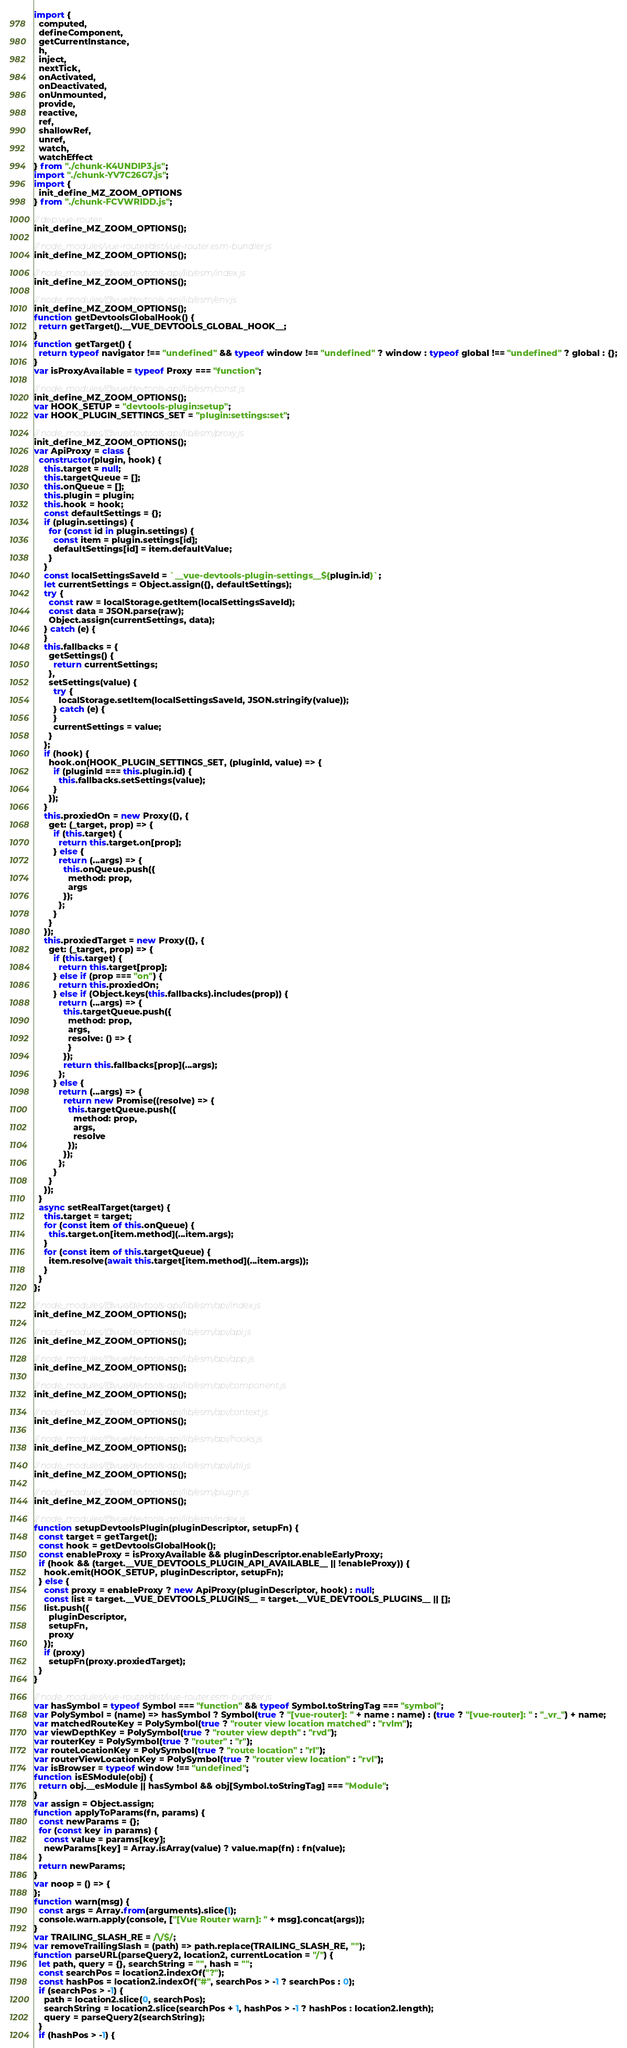Convert code to text. <code><loc_0><loc_0><loc_500><loc_500><_JavaScript_>import {
  computed,
  defineComponent,
  getCurrentInstance,
  h,
  inject,
  nextTick,
  onActivated,
  onDeactivated,
  onUnmounted,
  provide,
  reactive,
  ref,
  shallowRef,
  unref,
  watch,
  watchEffect
} from "./chunk-K4UNDIP3.js";
import "./chunk-YV7C26G7.js";
import {
  init_define_MZ_ZOOM_OPTIONS
} from "./chunk-FCVWRIDD.js";

// dep:vue-router
init_define_MZ_ZOOM_OPTIONS();

// node_modules/vue-router/dist/vue-router.esm-bundler.js
init_define_MZ_ZOOM_OPTIONS();

// node_modules/@vue/devtools-api/lib/esm/index.js
init_define_MZ_ZOOM_OPTIONS();

// node_modules/@vue/devtools-api/lib/esm/env.js
init_define_MZ_ZOOM_OPTIONS();
function getDevtoolsGlobalHook() {
  return getTarget().__VUE_DEVTOOLS_GLOBAL_HOOK__;
}
function getTarget() {
  return typeof navigator !== "undefined" && typeof window !== "undefined" ? window : typeof global !== "undefined" ? global : {};
}
var isProxyAvailable = typeof Proxy === "function";

// node_modules/@vue/devtools-api/lib/esm/const.js
init_define_MZ_ZOOM_OPTIONS();
var HOOK_SETUP = "devtools-plugin:setup";
var HOOK_PLUGIN_SETTINGS_SET = "plugin:settings:set";

// node_modules/@vue/devtools-api/lib/esm/proxy.js
init_define_MZ_ZOOM_OPTIONS();
var ApiProxy = class {
  constructor(plugin, hook) {
    this.target = null;
    this.targetQueue = [];
    this.onQueue = [];
    this.plugin = plugin;
    this.hook = hook;
    const defaultSettings = {};
    if (plugin.settings) {
      for (const id in plugin.settings) {
        const item = plugin.settings[id];
        defaultSettings[id] = item.defaultValue;
      }
    }
    const localSettingsSaveId = `__vue-devtools-plugin-settings__${plugin.id}`;
    let currentSettings = Object.assign({}, defaultSettings);
    try {
      const raw = localStorage.getItem(localSettingsSaveId);
      const data = JSON.parse(raw);
      Object.assign(currentSettings, data);
    } catch (e) {
    }
    this.fallbacks = {
      getSettings() {
        return currentSettings;
      },
      setSettings(value) {
        try {
          localStorage.setItem(localSettingsSaveId, JSON.stringify(value));
        } catch (e) {
        }
        currentSettings = value;
      }
    };
    if (hook) {
      hook.on(HOOK_PLUGIN_SETTINGS_SET, (pluginId, value) => {
        if (pluginId === this.plugin.id) {
          this.fallbacks.setSettings(value);
        }
      });
    }
    this.proxiedOn = new Proxy({}, {
      get: (_target, prop) => {
        if (this.target) {
          return this.target.on[prop];
        } else {
          return (...args) => {
            this.onQueue.push({
              method: prop,
              args
            });
          };
        }
      }
    });
    this.proxiedTarget = new Proxy({}, {
      get: (_target, prop) => {
        if (this.target) {
          return this.target[prop];
        } else if (prop === "on") {
          return this.proxiedOn;
        } else if (Object.keys(this.fallbacks).includes(prop)) {
          return (...args) => {
            this.targetQueue.push({
              method: prop,
              args,
              resolve: () => {
              }
            });
            return this.fallbacks[prop](...args);
          };
        } else {
          return (...args) => {
            return new Promise((resolve) => {
              this.targetQueue.push({
                method: prop,
                args,
                resolve
              });
            });
          };
        }
      }
    });
  }
  async setRealTarget(target) {
    this.target = target;
    for (const item of this.onQueue) {
      this.target.on[item.method](...item.args);
    }
    for (const item of this.targetQueue) {
      item.resolve(await this.target[item.method](...item.args));
    }
  }
};

// node_modules/@vue/devtools-api/lib/esm/api/index.js
init_define_MZ_ZOOM_OPTIONS();

// node_modules/@vue/devtools-api/lib/esm/api/api.js
init_define_MZ_ZOOM_OPTIONS();

// node_modules/@vue/devtools-api/lib/esm/api/app.js
init_define_MZ_ZOOM_OPTIONS();

// node_modules/@vue/devtools-api/lib/esm/api/component.js
init_define_MZ_ZOOM_OPTIONS();

// node_modules/@vue/devtools-api/lib/esm/api/context.js
init_define_MZ_ZOOM_OPTIONS();

// node_modules/@vue/devtools-api/lib/esm/api/hooks.js
init_define_MZ_ZOOM_OPTIONS();

// node_modules/@vue/devtools-api/lib/esm/api/util.js
init_define_MZ_ZOOM_OPTIONS();

// node_modules/@vue/devtools-api/lib/esm/plugin.js
init_define_MZ_ZOOM_OPTIONS();

// node_modules/@vue/devtools-api/lib/esm/index.js
function setupDevtoolsPlugin(pluginDescriptor, setupFn) {
  const target = getTarget();
  const hook = getDevtoolsGlobalHook();
  const enableProxy = isProxyAvailable && pluginDescriptor.enableEarlyProxy;
  if (hook && (target.__VUE_DEVTOOLS_PLUGIN_API_AVAILABLE__ || !enableProxy)) {
    hook.emit(HOOK_SETUP, pluginDescriptor, setupFn);
  } else {
    const proxy = enableProxy ? new ApiProxy(pluginDescriptor, hook) : null;
    const list = target.__VUE_DEVTOOLS_PLUGINS__ = target.__VUE_DEVTOOLS_PLUGINS__ || [];
    list.push({
      pluginDescriptor,
      setupFn,
      proxy
    });
    if (proxy)
      setupFn(proxy.proxiedTarget);
  }
}

// node_modules/vue-router/dist/vue-router.esm-bundler.js
var hasSymbol = typeof Symbol === "function" && typeof Symbol.toStringTag === "symbol";
var PolySymbol = (name) => hasSymbol ? Symbol(true ? "[vue-router]: " + name : name) : (true ? "[vue-router]: " : "_vr_") + name;
var matchedRouteKey = PolySymbol(true ? "router view location matched" : "rvlm");
var viewDepthKey = PolySymbol(true ? "router view depth" : "rvd");
var routerKey = PolySymbol(true ? "router" : "r");
var routeLocationKey = PolySymbol(true ? "route location" : "rl");
var routerViewLocationKey = PolySymbol(true ? "router view location" : "rvl");
var isBrowser = typeof window !== "undefined";
function isESModule(obj) {
  return obj.__esModule || hasSymbol && obj[Symbol.toStringTag] === "Module";
}
var assign = Object.assign;
function applyToParams(fn, params) {
  const newParams = {};
  for (const key in params) {
    const value = params[key];
    newParams[key] = Array.isArray(value) ? value.map(fn) : fn(value);
  }
  return newParams;
}
var noop = () => {
};
function warn(msg) {
  const args = Array.from(arguments).slice(1);
  console.warn.apply(console, ["[Vue Router warn]: " + msg].concat(args));
}
var TRAILING_SLASH_RE = /\/$/;
var removeTrailingSlash = (path) => path.replace(TRAILING_SLASH_RE, "");
function parseURL(parseQuery2, location2, currentLocation = "/") {
  let path, query = {}, searchString = "", hash = "";
  const searchPos = location2.indexOf("?");
  const hashPos = location2.indexOf("#", searchPos > -1 ? searchPos : 0);
  if (searchPos > -1) {
    path = location2.slice(0, searchPos);
    searchString = location2.slice(searchPos + 1, hashPos > -1 ? hashPos : location2.length);
    query = parseQuery2(searchString);
  }
  if (hashPos > -1) {</code> 